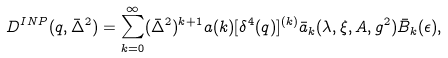Convert formula to latex. <formula><loc_0><loc_0><loc_500><loc_500>D ^ { I N P } ( q , \bar { \Delta } ^ { 2 } ) = \sum _ { k = 0 } ^ { \infty } ( \bar { \Delta } ^ { 2 } ) ^ { k + 1 } a ( k ) [ \delta ^ { 4 } ( q ) ] ^ { ( k ) } \bar { a } _ { k } ( \lambda , \xi , A , g ^ { 2 } ) \bar { B } _ { k } ( \epsilon ) ,</formula> 